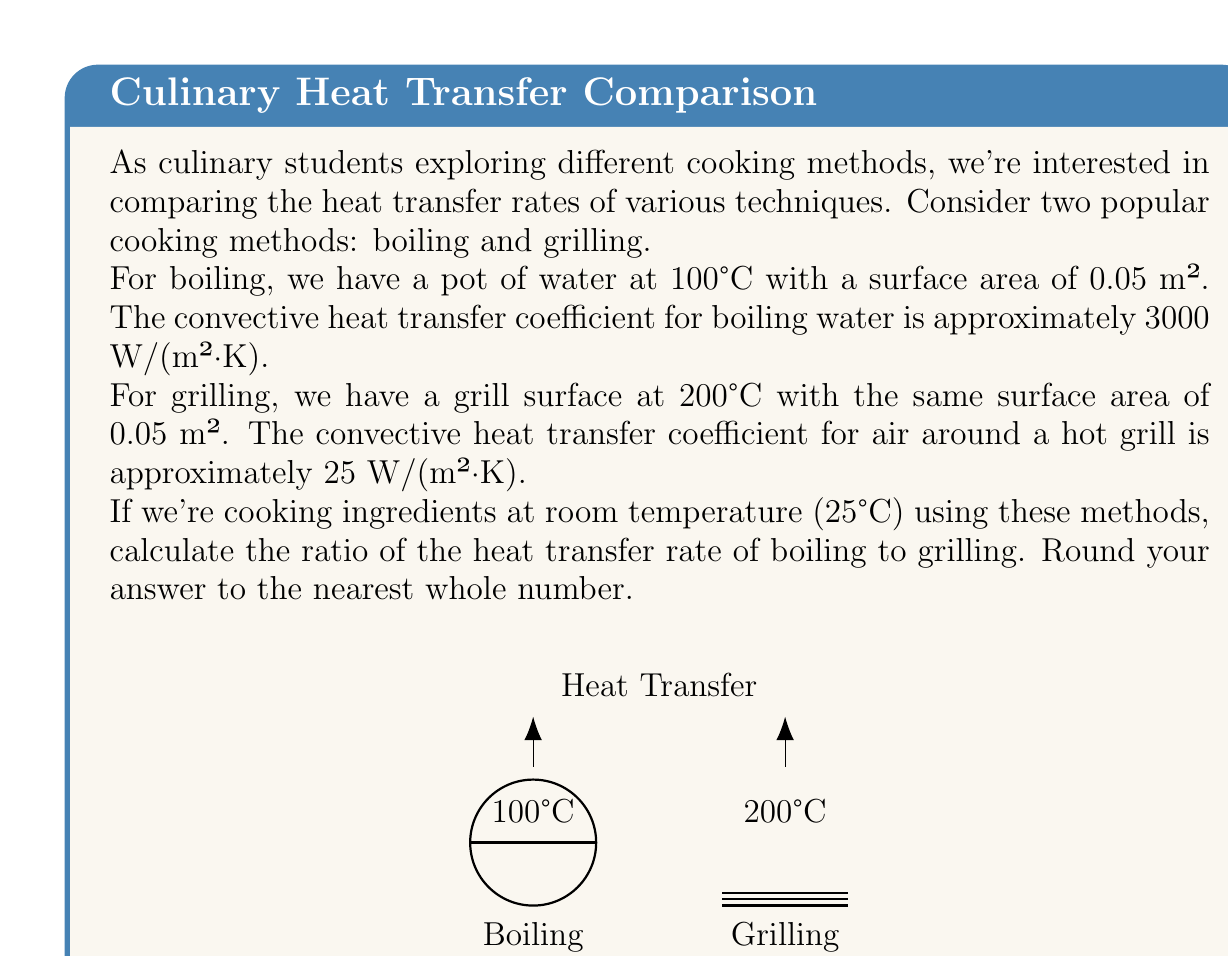Give your solution to this math problem. Let's approach this step-by-step:

1) The heat transfer rate $Q$ is given by Newton's Law of Cooling:

   $Q = hA(T_s - T_\infty)$

   where $h$ is the convective heat transfer coefficient, $A$ is the surface area, $T_s$ is the surface temperature, and $T_\infty$ is the temperature of the surrounding fluid (in this case, the food at room temperature).

2) For boiling:
   $Q_b = h_bA_b(T_{sb} - T_\infty)$
   $Q_b = 3000 \cdot 0.05 \cdot (100 - 25) = 11250$ W

3) For grilling:
   $Q_g = h_gA_g(T_{sg} - T_\infty)$
   $Q_g = 25 \cdot 0.05 \cdot (200 - 25) = 218.75$ W

4) The ratio of heat transfer rates is:
   $$\frac{Q_b}{Q_g} = \frac{11250}{218.75} = 51.43$$

5) Rounding to the nearest whole number: 51

This means the heat transfer rate for boiling is approximately 51 times greater than for grilling under these conditions.
Answer: 51 